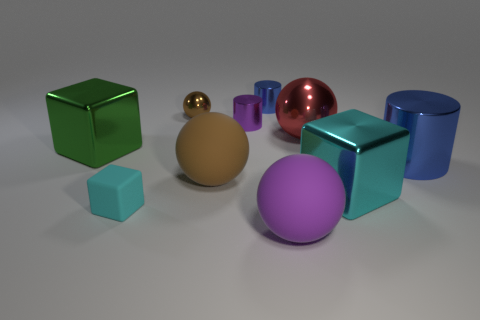What number of cyan matte cylinders have the same size as the rubber cube?
Keep it short and to the point. 0. There is a large green object that is the same shape as the small cyan rubber thing; what material is it?
Provide a short and direct response. Metal. There is a metal object that is on the left side of the large brown object and in front of the purple cylinder; what shape is it?
Provide a short and direct response. Cube. The brown thing that is in front of the green shiny block has what shape?
Make the answer very short. Sphere. How many metallic things are both left of the brown matte sphere and in front of the red metallic thing?
Give a very brief answer. 1. Is the size of the cyan metallic thing the same as the ball in front of the big cyan block?
Offer a terse response. Yes. What is the size of the blue cylinder that is right of the large metallic block to the right of the tiny object in front of the big blue thing?
Give a very brief answer. Large. There is a block that is right of the small purple shiny cylinder; what size is it?
Give a very brief answer. Large. There is a red object that is the same material as the tiny purple cylinder; what is its shape?
Your answer should be compact. Sphere. Does the blue thing left of the cyan metallic cube have the same material as the big cyan block?
Make the answer very short. Yes. 